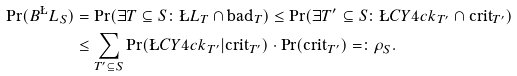Convert formula to latex. <formula><loc_0><loc_0><loc_500><loc_500>\Pr ( B ^ { \L } L _ { S } ) & = \Pr ( \exists T \subseteq S \colon \L L _ { T } \cap \text {bad} _ { T } ) \leq \Pr ( \exists T ^ { \prime } \subseteq S \colon \L C Y { 4 c k } _ { T ^ { \prime } } \cap \text {crit} _ { T ^ { \prime } } ) \\ & \leq \sum _ { T ^ { \prime } \subseteq S } \Pr ( \L C Y { 4 c k } _ { T ^ { \prime } } | \text {crit} _ { T ^ { \prime } } ) \cdot \Pr ( \text {crit} _ { T ^ { \prime } } ) = \colon \rho _ { S } .</formula> 